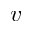<formula> <loc_0><loc_0><loc_500><loc_500>v</formula> 